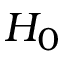Convert formula to latex. <formula><loc_0><loc_0><loc_500><loc_500>H _ { 0 }</formula> 